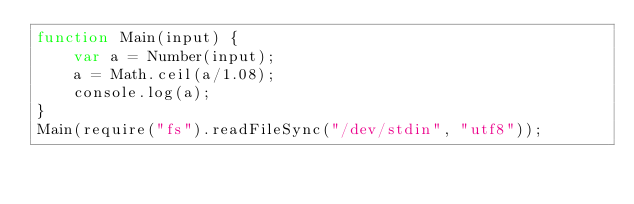Convert code to text. <code><loc_0><loc_0><loc_500><loc_500><_JavaScript_>function Main(input) {
	var a = Number(input);
	a = Math.ceil(a/1.08);
	console.log(a);
}
Main(require("fs").readFileSync("/dev/stdin", "utf8"));</code> 